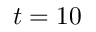Convert formula to latex. <formula><loc_0><loc_0><loc_500><loc_500>t = 1 0</formula> 